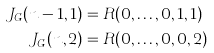<formula> <loc_0><loc_0><loc_500><loc_500>J _ { G } ( n - 1 , 1 ) & = R ( 0 , \dots , 0 , 1 , 1 ) \\ J _ { G } ( n , 2 ) & = R ( 0 , \dots , 0 , 0 , 2 )</formula> 